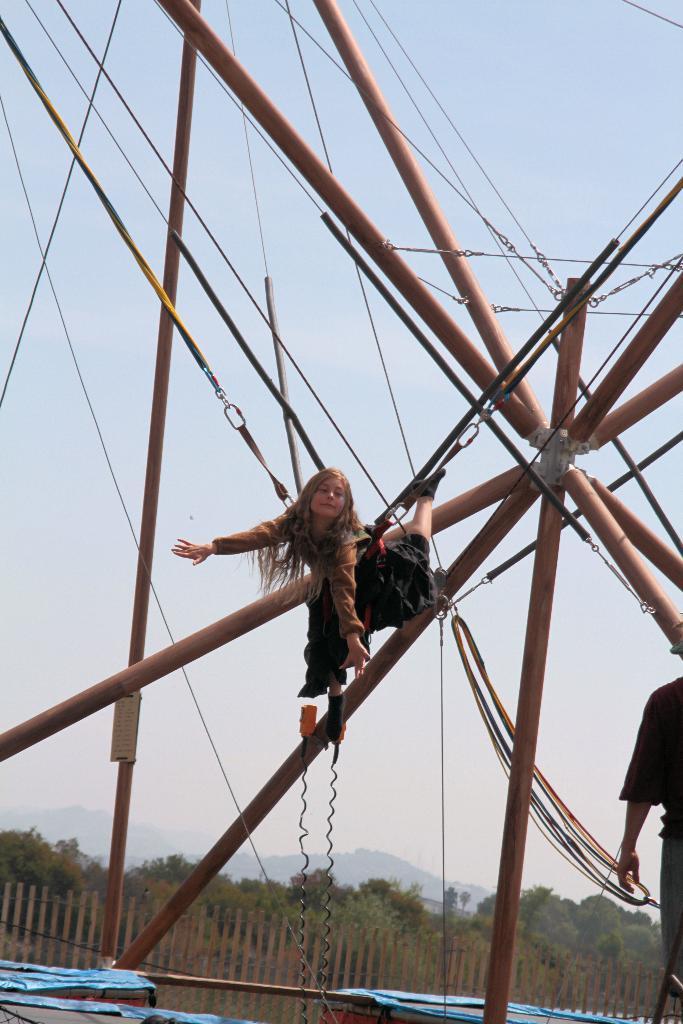Can you describe this image briefly? In this image there is a metal structure and there is a girl hanging with the helps of ropes. On the bottom left side of the image there is a person standing. In the background of the image there is a railing, trees, mountains and the sky. 